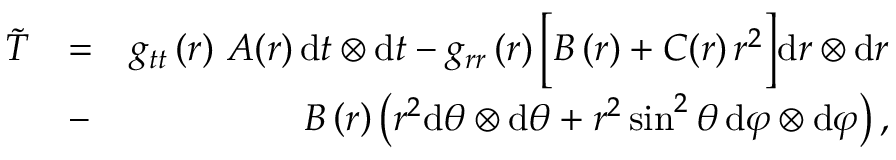<formula> <loc_0><loc_0><loc_500><loc_500>\begin{array} { r l r } { \widetilde { T } } & { = } & { g _ { t t } \left ( r \right ) \, A ( r ) \, d t \otimes d t - g _ { r r } \left ( r \right ) \left [ B \left ( r \right ) + C ( r ) \, r ^ { 2 } \right ] d r \otimes d r } \\ & { - } & { \, B \left ( r \right ) \left ( r ^ { 2 } d \theta \otimes d \theta + r ^ { 2 } \sin ^ { 2 } \theta \, d \varphi \otimes d \varphi \right ) , } \end{array}</formula> 